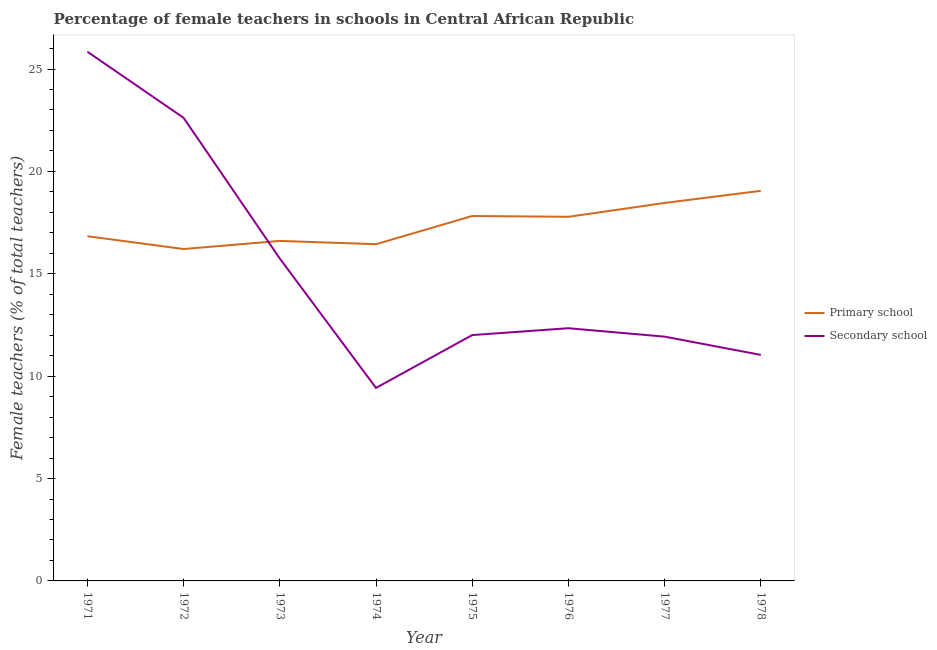How many different coloured lines are there?
Make the answer very short. 2. What is the percentage of female teachers in primary schools in 1975?
Ensure brevity in your answer.  17.82. Across all years, what is the maximum percentage of female teachers in primary schools?
Make the answer very short. 19.05. Across all years, what is the minimum percentage of female teachers in secondary schools?
Your response must be concise. 9.43. In which year was the percentage of female teachers in primary schools minimum?
Your response must be concise. 1972. What is the total percentage of female teachers in primary schools in the graph?
Provide a succinct answer. 139.21. What is the difference between the percentage of female teachers in secondary schools in 1973 and that in 1978?
Give a very brief answer. 4.71. What is the difference between the percentage of female teachers in secondary schools in 1976 and the percentage of female teachers in primary schools in 1973?
Offer a terse response. -4.26. What is the average percentage of female teachers in primary schools per year?
Make the answer very short. 17.4. In the year 1971, what is the difference between the percentage of female teachers in primary schools and percentage of female teachers in secondary schools?
Provide a short and direct response. -9.01. In how many years, is the percentage of female teachers in primary schools greater than 8 %?
Provide a short and direct response. 8. What is the ratio of the percentage of female teachers in primary schools in 1971 to that in 1974?
Your response must be concise. 1.02. Is the percentage of female teachers in primary schools in 1974 less than that in 1978?
Give a very brief answer. Yes. What is the difference between the highest and the second highest percentage of female teachers in secondary schools?
Offer a terse response. 3.23. What is the difference between the highest and the lowest percentage of female teachers in secondary schools?
Provide a succinct answer. 16.42. In how many years, is the percentage of female teachers in primary schools greater than the average percentage of female teachers in primary schools taken over all years?
Provide a succinct answer. 4. Is the sum of the percentage of female teachers in primary schools in 1973 and 1975 greater than the maximum percentage of female teachers in secondary schools across all years?
Give a very brief answer. Yes. Does the percentage of female teachers in secondary schools monotonically increase over the years?
Your answer should be compact. No. Is the percentage of female teachers in secondary schools strictly less than the percentage of female teachers in primary schools over the years?
Offer a terse response. No. How many lines are there?
Provide a short and direct response. 2. Does the graph contain any zero values?
Offer a terse response. No. Does the graph contain grids?
Keep it short and to the point. No. Where does the legend appear in the graph?
Ensure brevity in your answer.  Center right. How many legend labels are there?
Ensure brevity in your answer.  2. How are the legend labels stacked?
Make the answer very short. Vertical. What is the title of the graph?
Keep it short and to the point. Percentage of female teachers in schools in Central African Republic. What is the label or title of the X-axis?
Make the answer very short. Year. What is the label or title of the Y-axis?
Keep it short and to the point. Female teachers (% of total teachers). What is the Female teachers (% of total teachers) in Primary school in 1971?
Provide a short and direct response. 16.84. What is the Female teachers (% of total teachers) of Secondary school in 1971?
Provide a short and direct response. 25.85. What is the Female teachers (% of total teachers) of Primary school in 1972?
Ensure brevity in your answer.  16.21. What is the Female teachers (% of total teachers) of Secondary school in 1972?
Offer a terse response. 22.62. What is the Female teachers (% of total teachers) in Primary school in 1973?
Your response must be concise. 16.6. What is the Female teachers (% of total teachers) in Secondary school in 1973?
Keep it short and to the point. 15.75. What is the Female teachers (% of total teachers) in Primary school in 1974?
Provide a short and direct response. 16.45. What is the Female teachers (% of total teachers) in Secondary school in 1974?
Ensure brevity in your answer.  9.43. What is the Female teachers (% of total teachers) in Primary school in 1975?
Your answer should be very brief. 17.82. What is the Female teachers (% of total teachers) of Secondary school in 1975?
Offer a very short reply. 12.01. What is the Female teachers (% of total teachers) in Primary school in 1976?
Provide a short and direct response. 17.78. What is the Female teachers (% of total teachers) in Secondary school in 1976?
Your response must be concise. 12.34. What is the Female teachers (% of total teachers) of Primary school in 1977?
Provide a succinct answer. 18.46. What is the Female teachers (% of total teachers) of Secondary school in 1977?
Keep it short and to the point. 11.93. What is the Female teachers (% of total teachers) in Primary school in 1978?
Offer a very short reply. 19.05. What is the Female teachers (% of total teachers) in Secondary school in 1978?
Make the answer very short. 11.04. Across all years, what is the maximum Female teachers (% of total teachers) of Primary school?
Give a very brief answer. 19.05. Across all years, what is the maximum Female teachers (% of total teachers) of Secondary school?
Offer a very short reply. 25.85. Across all years, what is the minimum Female teachers (% of total teachers) in Primary school?
Your response must be concise. 16.21. Across all years, what is the minimum Female teachers (% of total teachers) in Secondary school?
Your response must be concise. 9.43. What is the total Female teachers (% of total teachers) of Primary school in the graph?
Make the answer very short. 139.21. What is the total Female teachers (% of total teachers) of Secondary school in the graph?
Offer a very short reply. 120.95. What is the difference between the Female teachers (% of total teachers) in Primary school in 1971 and that in 1972?
Give a very brief answer. 0.63. What is the difference between the Female teachers (% of total teachers) in Secondary school in 1971 and that in 1972?
Offer a terse response. 3.23. What is the difference between the Female teachers (% of total teachers) of Primary school in 1971 and that in 1973?
Provide a succinct answer. 0.23. What is the difference between the Female teachers (% of total teachers) in Secondary school in 1971 and that in 1973?
Offer a terse response. 10.1. What is the difference between the Female teachers (% of total teachers) in Primary school in 1971 and that in 1974?
Your answer should be very brief. 0.39. What is the difference between the Female teachers (% of total teachers) of Secondary school in 1971 and that in 1974?
Provide a short and direct response. 16.42. What is the difference between the Female teachers (% of total teachers) in Primary school in 1971 and that in 1975?
Make the answer very short. -0.99. What is the difference between the Female teachers (% of total teachers) of Secondary school in 1971 and that in 1975?
Your response must be concise. 13.84. What is the difference between the Female teachers (% of total teachers) of Primary school in 1971 and that in 1976?
Your response must be concise. -0.95. What is the difference between the Female teachers (% of total teachers) of Secondary school in 1971 and that in 1976?
Provide a succinct answer. 13.51. What is the difference between the Female teachers (% of total teachers) of Primary school in 1971 and that in 1977?
Provide a short and direct response. -1.62. What is the difference between the Female teachers (% of total teachers) in Secondary school in 1971 and that in 1977?
Your response must be concise. 13.92. What is the difference between the Female teachers (% of total teachers) in Primary school in 1971 and that in 1978?
Provide a short and direct response. -2.22. What is the difference between the Female teachers (% of total teachers) in Secondary school in 1971 and that in 1978?
Your answer should be compact. 14.81. What is the difference between the Female teachers (% of total teachers) of Primary school in 1972 and that in 1973?
Give a very brief answer. -0.4. What is the difference between the Female teachers (% of total teachers) in Secondary school in 1972 and that in 1973?
Provide a succinct answer. 6.87. What is the difference between the Female teachers (% of total teachers) of Primary school in 1972 and that in 1974?
Your response must be concise. -0.24. What is the difference between the Female teachers (% of total teachers) of Secondary school in 1972 and that in 1974?
Your answer should be compact. 13.19. What is the difference between the Female teachers (% of total teachers) in Primary school in 1972 and that in 1975?
Keep it short and to the point. -1.61. What is the difference between the Female teachers (% of total teachers) in Secondary school in 1972 and that in 1975?
Your answer should be compact. 10.61. What is the difference between the Female teachers (% of total teachers) of Primary school in 1972 and that in 1976?
Keep it short and to the point. -1.57. What is the difference between the Female teachers (% of total teachers) in Secondary school in 1972 and that in 1976?
Offer a terse response. 10.28. What is the difference between the Female teachers (% of total teachers) of Primary school in 1972 and that in 1977?
Your answer should be compact. -2.25. What is the difference between the Female teachers (% of total teachers) of Secondary school in 1972 and that in 1977?
Provide a succinct answer. 10.69. What is the difference between the Female teachers (% of total teachers) in Primary school in 1972 and that in 1978?
Provide a succinct answer. -2.84. What is the difference between the Female teachers (% of total teachers) in Secondary school in 1972 and that in 1978?
Offer a terse response. 11.58. What is the difference between the Female teachers (% of total teachers) in Primary school in 1973 and that in 1974?
Make the answer very short. 0.16. What is the difference between the Female teachers (% of total teachers) in Secondary school in 1973 and that in 1974?
Give a very brief answer. 6.32. What is the difference between the Female teachers (% of total teachers) in Primary school in 1973 and that in 1975?
Give a very brief answer. -1.22. What is the difference between the Female teachers (% of total teachers) of Secondary school in 1973 and that in 1975?
Provide a short and direct response. 3.74. What is the difference between the Female teachers (% of total teachers) in Primary school in 1973 and that in 1976?
Your answer should be very brief. -1.18. What is the difference between the Female teachers (% of total teachers) of Secondary school in 1973 and that in 1976?
Your answer should be compact. 3.4. What is the difference between the Female teachers (% of total teachers) in Primary school in 1973 and that in 1977?
Keep it short and to the point. -1.85. What is the difference between the Female teachers (% of total teachers) in Secondary school in 1973 and that in 1977?
Make the answer very short. 3.82. What is the difference between the Female teachers (% of total teachers) of Primary school in 1973 and that in 1978?
Provide a short and direct response. -2.45. What is the difference between the Female teachers (% of total teachers) of Secondary school in 1973 and that in 1978?
Make the answer very short. 4.71. What is the difference between the Female teachers (% of total teachers) of Primary school in 1974 and that in 1975?
Provide a short and direct response. -1.38. What is the difference between the Female teachers (% of total teachers) in Secondary school in 1974 and that in 1975?
Your answer should be compact. -2.58. What is the difference between the Female teachers (% of total teachers) in Primary school in 1974 and that in 1976?
Ensure brevity in your answer.  -1.34. What is the difference between the Female teachers (% of total teachers) in Secondary school in 1974 and that in 1976?
Give a very brief answer. -2.92. What is the difference between the Female teachers (% of total teachers) in Primary school in 1974 and that in 1977?
Offer a terse response. -2.01. What is the difference between the Female teachers (% of total teachers) of Secondary school in 1974 and that in 1977?
Your answer should be compact. -2.5. What is the difference between the Female teachers (% of total teachers) in Primary school in 1974 and that in 1978?
Offer a very short reply. -2.61. What is the difference between the Female teachers (% of total teachers) of Secondary school in 1974 and that in 1978?
Your answer should be very brief. -1.61. What is the difference between the Female teachers (% of total teachers) in Primary school in 1975 and that in 1976?
Provide a succinct answer. 0.04. What is the difference between the Female teachers (% of total teachers) in Secondary school in 1975 and that in 1976?
Give a very brief answer. -0.33. What is the difference between the Female teachers (% of total teachers) in Primary school in 1975 and that in 1977?
Offer a very short reply. -0.64. What is the difference between the Female teachers (% of total teachers) in Secondary school in 1975 and that in 1977?
Your response must be concise. 0.08. What is the difference between the Female teachers (% of total teachers) of Primary school in 1975 and that in 1978?
Provide a short and direct response. -1.23. What is the difference between the Female teachers (% of total teachers) in Secondary school in 1975 and that in 1978?
Offer a terse response. 0.97. What is the difference between the Female teachers (% of total teachers) of Primary school in 1976 and that in 1977?
Give a very brief answer. -0.68. What is the difference between the Female teachers (% of total teachers) in Secondary school in 1976 and that in 1977?
Make the answer very short. 0.41. What is the difference between the Female teachers (% of total teachers) of Primary school in 1976 and that in 1978?
Make the answer very short. -1.27. What is the difference between the Female teachers (% of total teachers) in Secondary school in 1976 and that in 1978?
Your answer should be compact. 1.3. What is the difference between the Female teachers (% of total teachers) of Primary school in 1977 and that in 1978?
Ensure brevity in your answer.  -0.59. What is the difference between the Female teachers (% of total teachers) in Secondary school in 1977 and that in 1978?
Offer a very short reply. 0.89. What is the difference between the Female teachers (% of total teachers) of Primary school in 1971 and the Female teachers (% of total teachers) of Secondary school in 1972?
Keep it short and to the point. -5.78. What is the difference between the Female teachers (% of total teachers) in Primary school in 1971 and the Female teachers (% of total teachers) in Secondary school in 1973?
Give a very brief answer. 1.09. What is the difference between the Female teachers (% of total teachers) in Primary school in 1971 and the Female teachers (% of total teachers) in Secondary school in 1974?
Your answer should be very brief. 7.41. What is the difference between the Female teachers (% of total teachers) in Primary school in 1971 and the Female teachers (% of total teachers) in Secondary school in 1975?
Give a very brief answer. 4.83. What is the difference between the Female teachers (% of total teachers) in Primary school in 1971 and the Female teachers (% of total teachers) in Secondary school in 1976?
Provide a succinct answer. 4.49. What is the difference between the Female teachers (% of total teachers) in Primary school in 1971 and the Female teachers (% of total teachers) in Secondary school in 1977?
Provide a succinct answer. 4.91. What is the difference between the Female teachers (% of total teachers) in Primary school in 1971 and the Female teachers (% of total teachers) in Secondary school in 1978?
Make the answer very short. 5.8. What is the difference between the Female teachers (% of total teachers) of Primary school in 1972 and the Female teachers (% of total teachers) of Secondary school in 1973?
Keep it short and to the point. 0.46. What is the difference between the Female teachers (% of total teachers) of Primary school in 1972 and the Female teachers (% of total teachers) of Secondary school in 1974?
Provide a succinct answer. 6.78. What is the difference between the Female teachers (% of total teachers) in Primary school in 1972 and the Female teachers (% of total teachers) in Secondary school in 1975?
Provide a short and direct response. 4.2. What is the difference between the Female teachers (% of total teachers) of Primary school in 1972 and the Female teachers (% of total teachers) of Secondary school in 1976?
Keep it short and to the point. 3.87. What is the difference between the Female teachers (% of total teachers) of Primary school in 1972 and the Female teachers (% of total teachers) of Secondary school in 1977?
Your answer should be very brief. 4.28. What is the difference between the Female teachers (% of total teachers) of Primary school in 1972 and the Female teachers (% of total teachers) of Secondary school in 1978?
Offer a terse response. 5.17. What is the difference between the Female teachers (% of total teachers) in Primary school in 1973 and the Female teachers (% of total teachers) in Secondary school in 1974?
Give a very brief answer. 7.18. What is the difference between the Female teachers (% of total teachers) of Primary school in 1973 and the Female teachers (% of total teachers) of Secondary school in 1975?
Provide a short and direct response. 4.6. What is the difference between the Female teachers (% of total teachers) of Primary school in 1973 and the Female teachers (% of total teachers) of Secondary school in 1976?
Ensure brevity in your answer.  4.26. What is the difference between the Female teachers (% of total teachers) of Primary school in 1973 and the Female teachers (% of total teachers) of Secondary school in 1977?
Your answer should be compact. 4.67. What is the difference between the Female teachers (% of total teachers) in Primary school in 1973 and the Female teachers (% of total teachers) in Secondary school in 1978?
Provide a short and direct response. 5.57. What is the difference between the Female teachers (% of total teachers) in Primary school in 1974 and the Female teachers (% of total teachers) in Secondary school in 1975?
Make the answer very short. 4.44. What is the difference between the Female teachers (% of total teachers) in Primary school in 1974 and the Female teachers (% of total teachers) in Secondary school in 1976?
Make the answer very short. 4.1. What is the difference between the Female teachers (% of total teachers) in Primary school in 1974 and the Female teachers (% of total teachers) in Secondary school in 1977?
Your response must be concise. 4.51. What is the difference between the Female teachers (% of total teachers) in Primary school in 1974 and the Female teachers (% of total teachers) in Secondary school in 1978?
Offer a very short reply. 5.41. What is the difference between the Female teachers (% of total teachers) of Primary school in 1975 and the Female teachers (% of total teachers) of Secondary school in 1976?
Offer a terse response. 5.48. What is the difference between the Female teachers (% of total teachers) in Primary school in 1975 and the Female teachers (% of total teachers) in Secondary school in 1977?
Ensure brevity in your answer.  5.89. What is the difference between the Female teachers (% of total teachers) of Primary school in 1975 and the Female teachers (% of total teachers) of Secondary school in 1978?
Ensure brevity in your answer.  6.78. What is the difference between the Female teachers (% of total teachers) of Primary school in 1976 and the Female teachers (% of total teachers) of Secondary school in 1977?
Give a very brief answer. 5.85. What is the difference between the Female teachers (% of total teachers) of Primary school in 1976 and the Female teachers (% of total teachers) of Secondary school in 1978?
Your response must be concise. 6.74. What is the difference between the Female teachers (% of total teachers) in Primary school in 1977 and the Female teachers (% of total teachers) in Secondary school in 1978?
Provide a succinct answer. 7.42. What is the average Female teachers (% of total teachers) of Primary school per year?
Ensure brevity in your answer.  17.4. What is the average Female teachers (% of total teachers) of Secondary school per year?
Make the answer very short. 15.12. In the year 1971, what is the difference between the Female teachers (% of total teachers) in Primary school and Female teachers (% of total teachers) in Secondary school?
Your answer should be compact. -9.01. In the year 1972, what is the difference between the Female teachers (% of total teachers) in Primary school and Female teachers (% of total teachers) in Secondary school?
Offer a very short reply. -6.41. In the year 1973, what is the difference between the Female teachers (% of total teachers) of Primary school and Female teachers (% of total teachers) of Secondary school?
Your response must be concise. 0.86. In the year 1974, what is the difference between the Female teachers (% of total teachers) in Primary school and Female teachers (% of total teachers) in Secondary school?
Keep it short and to the point. 7.02. In the year 1975, what is the difference between the Female teachers (% of total teachers) in Primary school and Female teachers (% of total teachers) in Secondary school?
Give a very brief answer. 5.82. In the year 1976, what is the difference between the Female teachers (% of total teachers) of Primary school and Female teachers (% of total teachers) of Secondary school?
Your response must be concise. 5.44. In the year 1977, what is the difference between the Female teachers (% of total teachers) of Primary school and Female teachers (% of total teachers) of Secondary school?
Ensure brevity in your answer.  6.53. In the year 1978, what is the difference between the Female teachers (% of total teachers) of Primary school and Female teachers (% of total teachers) of Secondary school?
Your answer should be compact. 8.01. What is the ratio of the Female teachers (% of total teachers) of Primary school in 1971 to that in 1972?
Offer a terse response. 1.04. What is the ratio of the Female teachers (% of total teachers) of Secondary school in 1971 to that in 1972?
Make the answer very short. 1.14. What is the ratio of the Female teachers (% of total teachers) of Primary school in 1971 to that in 1973?
Provide a succinct answer. 1.01. What is the ratio of the Female teachers (% of total teachers) of Secondary school in 1971 to that in 1973?
Keep it short and to the point. 1.64. What is the ratio of the Female teachers (% of total teachers) in Primary school in 1971 to that in 1974?
Offer a very short reply. 1.02. What is the ratio of the Female teachers (% of total teachers) of Secondary school in 1971 to that in 1974?
Your answer should be very brief. 2.74. What is the ratio of the Female teachers (% of total teachers) of Primary school in 1971 to that in 1975?
Your answer should be very brief. 0.94. What is the ratio of the Female teachers (% of total teachers) of Secondary school in 1971 to that in 1975?
Ensure brevity in your answer.  2.15. What is the ratio of the Female teachers (% of total teachers) of Primary school in 1971 to that in 1976?
Make the answer very short. 0.95. What is the ratio of the Female teachers (% of total teachers) in Secondary school in 1971 to that in 1976?
Your response must be concise. 2.09. What is the ratio of the Female teachers (% of total teachers) of Primary school in 1971 to that in 1977?
Offer a terse response. 0.91. What is the ratio of the Female teachers (% of total teachers) in Secondary school in 1971 to that in 1977?
Offer a very short reply. 2.17. What is the ratio of the Female teachers (% of total teachers) in Primary school in 1971 to that in 1978?
Make the answer very short. 0.88. What is the ratio of the Female teachers (% of total teachers) in Secondary school in 1971 to that in 1978?
Offer a very short reply. 2.34. What is the ratio of the Female teachers (% of total teachers) of Primary school in 1972 to that in 1973?
Your answer should be very brief. 0.98. What is the ratio of the Female teachers (% of total teachers) of Secondary school in 1972 to that in 1973?
Keep it short and to the point. 1.44. What is the ratio of the Female teachers (% of total teachers) of Primary school in 1972 to that in 1974?
Offer a very short reply. 0.99. What is the ratio of the Female teachers (% of total teachers) in Secondary school in 1972 to that in 1974?
Keep it short and to the point. 2.4. What is the ratio of the Female teachers (% of total teachers) of Primary school in 1972 to that in 1975?
Offer a very short reply. 0.91. What is the ratio of the Female teachers (% of total teachers) in Secondary school in 1972 to that in 1975?
Give a very brief answer. 1.88. What is the ratio of the Female teachers (% of total teachers) of Primary school in 1972 to that in 1976?
Offer a very short reply. 0.91. What is the ratio of the Female teachers (% of total teachers) of Secondary school in 1972 to that in 1976?
Give a very brief answer. 1.83. What is the ratio of the Female teachers (% of total teachers) in Primary school in 1972 to that in 1977?
Provide a succinct answer. 0.88. What is the ratio of the Female teachers (% of total teachers) of Secondary school in 1972 to that in 1977?
Provide a succinct answer. 1.9. What is the ratio of the Female teachers (% of total teachers) in Primary school in 1972 to that in 1978?
Give a very brief answer. 0.85. What is the ratio of the Female teachers (% of total teachers) of Secondary school in 1972 to that in 1978?
Give a very brief answer. 2.05. What is the ratio of the Female teachers (% of total teachers) in Primary school in 1973 to that in 1974?
Ensure brevity in your answer.  1.01. What is the ratio of the Female teachers (% of total teachers) in Secondary school in 1973 to that in 1974?
Your answer should be compact. 1.67. What is the ratio of the Female teachers (% of total teachers) in Primary school in 1973 to that in 1975?
Give a very brief answer. 0.93. What is the ratio of the Female teachers (% of total teachers) in Secondary school in 1973 to that in 1975?
Offer a terse response. 1.31. What is the ratio of the Female teachers (% of total teachers) in Primary school in 1973 to that in 1976?
Make the answer very short. 0.93. What is the ratio of the Female teachers (% of total teachers) of Secondary school in 1973 to that in 1976?
Your answer should be compact. 1.28. What is the ratio of the Female teachers (% of total teachers) of Primary school in 1973 to that in 1977?
Your answer should be very brief. 0.9. What is the ratio of the Female teachers (% of total teachers) of Secondary school in 1973 to that in 1977?
Make the answer very short. 1.32. What is the ratio of the Female teachers (% of total teachers) in Primary school in 1973 to that in 1978?
Provide a short and direct response. 0.87. What is the ratio of the Female teachers (% of total teachers) of Secondary school in 1973 to that in 1978?
Provide a succinct answer. 1.43. What is the ratio of the Female teachers (% of total teachers) in Primary school in 1974 to that in 1975?
Your response must be concise. 0.92. What is the ratio of the Female teachers (% of total teachers) in Secondary school in 1974 to that in 1975?
Ensure brevity in your answer.  0.79. What is the ratio of the Female teachers (% of total teachers) in Primary school in 1974 to that in 1976?
Your answer should be very brief. 0.92. What is the ratio of the Female teachers (% of total teachers) of Secondary school in 1974 to that in 1976?
Ensure brevity in your answer.  0.76. What is the ratio of the Female teachers (% of total teachers) of Primary school in 1974 to that in 1977?
Provide a succinct answer. 0.89. What is the ratio of the Female teachers (% of total teachers) of Secondary school in 1974 to that in 1977?
Your answer should be compact. 0.79. What is the ratio of the Female teachers (% of total teachers) in Primary school in 1974 to that in 1978?
Ensure brevity in your answer.  0.86. What is the ratio of the Female teachers (% of total teachers) of Secondary school in 1974 to that in 1978?
Give a very brief answer. 0.85. What is the ratio of the Female teachers (% of total teachers) of Secondary school in 1975 to that in 1976?
Your answer should be compact. 0.97. What is the ratio of the Female teachers (% of total teachers) of Primary school in 1975 to that in 1977?
Your answer should be compact. 0.97. What is the ratio of the Female teachers (% of total teachers) in Secondary school in 1975 to that in 1977?
Give a very brief answer. 1.01. What is the ratio of the Female teachers (% of total teachers) in Primary school in 1975 to that in 1978?
Provide a succinct answer. 0.94. What is the ratio of the Female teachers (% of total teachers) of Secondary school in 1975 to that in 1978?
Your answer should be very brief. 1.09. What is the ratio of the Female teachers (% of total teachers) in Primary school in 1976 to that in 1977?
Give a very brief answer. 0.96. What is the ratio of the Female teachers (% of total teachers) of Secondary school in 1976 to that in 1977?
Make the answer very short. 1.03. What is the ratio of the Female teachers (% of total teachers) in Primary school in 1976 to that in 1978?
Your answer should be very brief. 0.93. What is the ratio of the Female teachers (% of total teachers) in Secondary school in 1976 to that in 1978?
Your answer should be very brief. 1.12. What is the ratio of the Female teachers (% of total teachers) in Primary school in 1977 to that in 1978?
Offer a terse response. 0.97. What is the ratio of the Female teachers (% of total teachers) of Secondary school in 1977 to that in 1978?
Ensure brevity in your answer.  1.08. What is the difference between the highest and the second highest Female teachers (% of total teachers) in Primary school?
Offer a very short reply. 0.59. What is the difference between the highest and the second highest Female teachers (% of total teachers) of Secondary school?
Make the answer very short. 3.23. What is the difference between the highest and the lowest Female teachers (% of total teachers) of Primary school?
Make the answer very short. 2.84. What is the difference between the highest and the lowest Female teachers (% of total teachers) of Secondary school?
Keep it short and to the point. 16.42. 